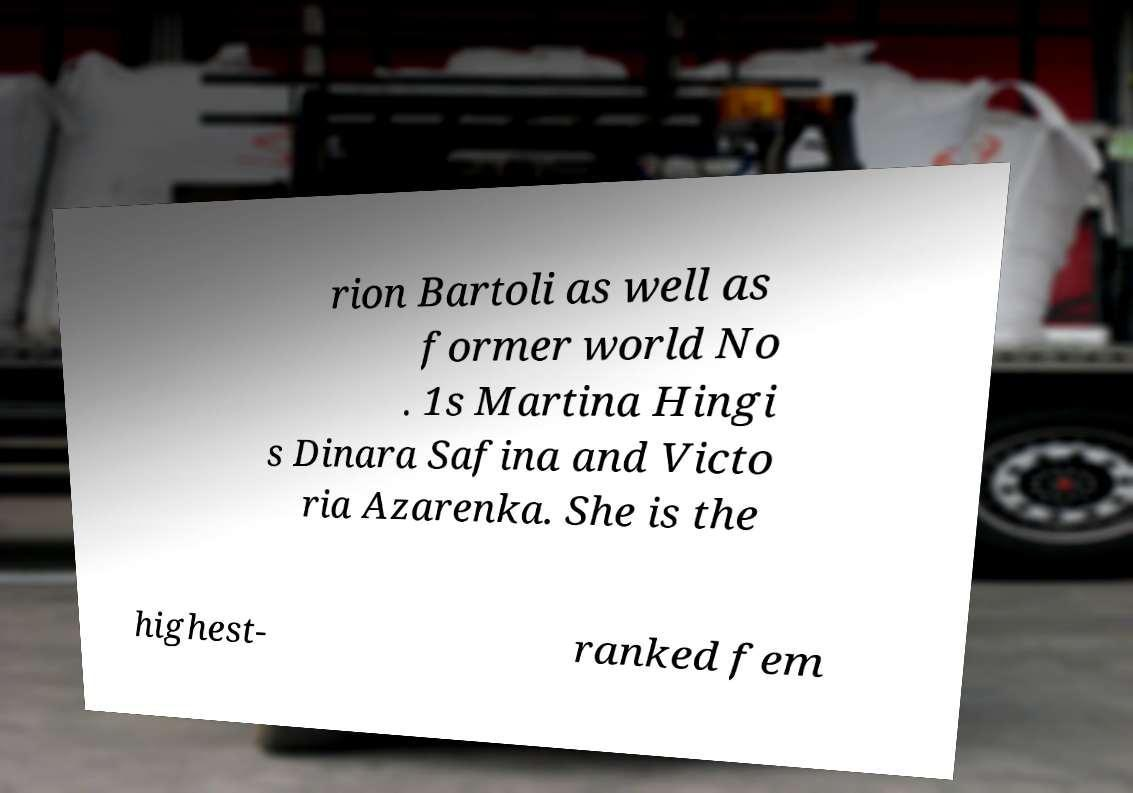Please read and relay the text visible in this image. What does it say? rion Bartoli as well as former world No . 1s Martina Hingi s Dinara Safina and Victo ria Azarenka. She is the highest- ranked fem 